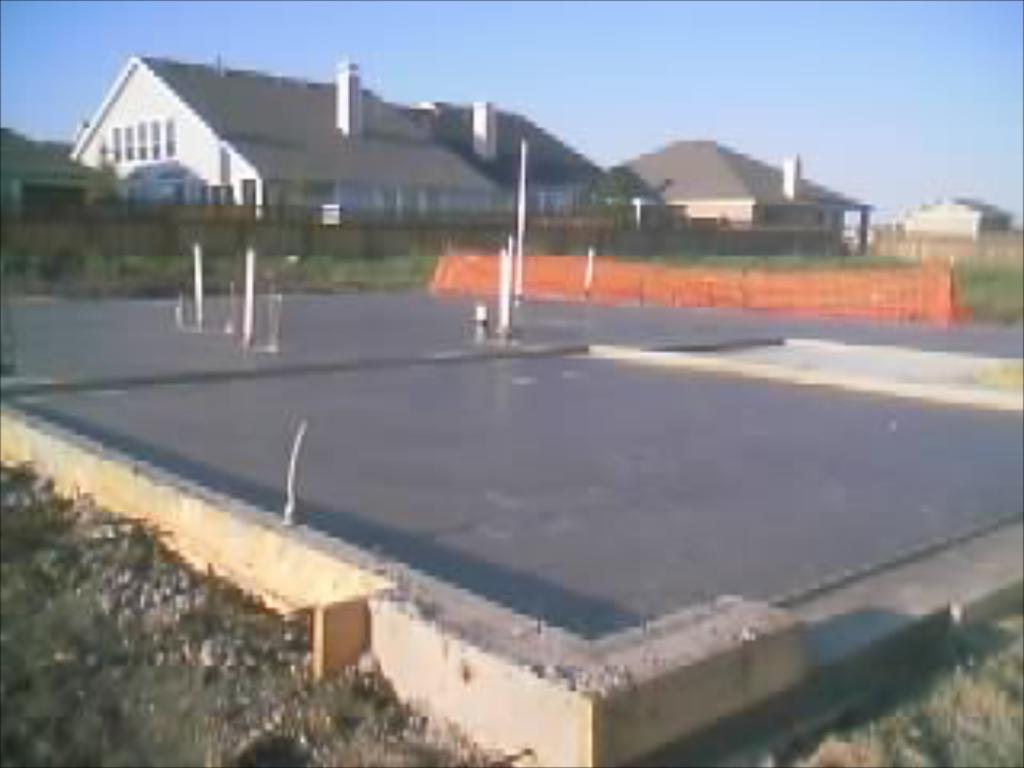What is the main subject of the image? The main subject of the image is a car parking place. Are there any structures visible behind the car parking place? Yes, there are houses behind the car parking place. How many snakes can be seen slithering around the car parking place in the image? There are no snakes present in the image; it features a car parking place and houses. What type of bucket is used to clean the cars in the image? There is no bucket or car cleaning activity depicted in the image. 